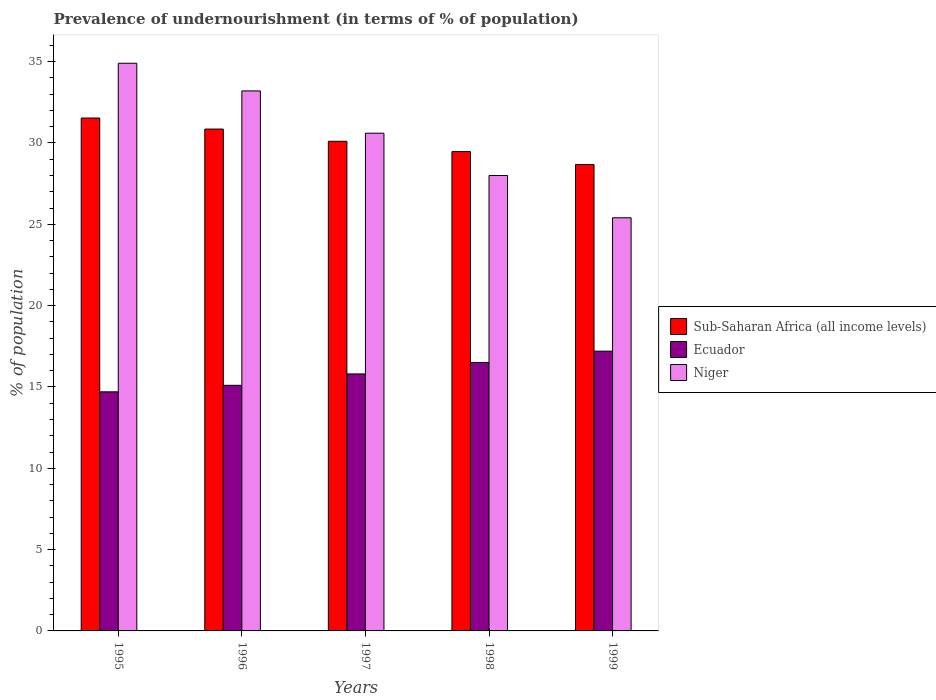How many groups of bars are there?
Make the answer very short. 5. How many bars are there on the 4th tick from the left?
Your answer should be compact. 3. How many bars are there on the 4th tick from the right?
Ensure brevity in your answer.  3. What is the label of the 4th group of bars from the left?
Your answer should be very brief. 1998. In how many cases, is the number of bars for a given year not equal to the number of legend labels?
Your answer should be very brief. 0. What is the percentage of undernourished population in Sub-Saharan Africa (all income levels) in 1996?
Your answer should be very brief. 30.85. Across all years, what is the maximum percentage of undernourished population in Niger?
Make the answer very short. 34.9. Across all years, what is the minimum percentage of undernourished population in Ecuador?
Provide a short and direct response. 14.7. What is the total percentage of undernourished population in Sub-Saharan Africa (all income levels) in the graph?
Give a very brief answer. 150.63. What is the difference between the percentage of undernourished population in Sub-Saharan Africa (all income levels) in 1996 and the percentage of undernourished population in Ecuador in 1995?
Keep it short and to the point. 16.15. What is the average percentage of undernourished population in Niger per year?
Offer a terse response. 30.42. In the year 1996, what is the difference between the percentage of undernourished population in Sub-Saharan Africa (all income levels) and percentage of undernourished population in Niger?
Ensure brevity in your answer.  -2.35. What is the ratio of the percentage of undernourished population in Niger in 1995 to that in 1998?
Provide a succinct answer. 1.25. Is the percentage of undernourished population in Sub-Saharan Africa (all income levels) in 1995 less than that in 1998?
Provide a succinct answer. No. Is the difference between the percentage of undernourished population in Sub-Saharan Africa (all income levels) in 1995 and 1998 greater than the difference between the percentage of undernourished population in Niger in 1995 and 1998?
Your answer should be very brief. No. What is the difference between the highest and the second highest percentage of undernourished population in Niger?
Ensure brevity in your answer.  1.7. Is the sum of the percentage of undernourished population in Ecuador in 1995 and 1997 greater than the maximum percentage of undernourished population in Sub-Saharan Africa (all income levels) across all years?
Give a very brief answer. No. What does the 1st bar from the left in 1997 represents?
Make the answer very short. Sub-Saharan Africa (all income levels). What does the 3rd bar from the right in 1998 represents?
Keep it short and to the point. Sub-Saharan Africa (all income levels). Is it the case that in every year, the sum of the percentage of undernourished population in Ecuador and percentage of undernourished population in Sub-Saharan Africa (all income levels) is greater than the percentage of undernourished population in Niger?
Provide a succinct answer. Yes. How many bars are there?
Offer a very short reply. 15. Are all the bars in the graph horizontal?
Make the answer very short. No. What is the difference between two consecutive major ticks on the Y-axis?
Keep it short and to the point. 5. Does the graph contain any zero values?
Your answer should be compact. No. Where does the legend appear in the graph?
Ensure brevity in your answer.  Center right. What is the title of the graph?
Give a very brief answer. Prevalence of undernourishment (in terms of % of population). What is the label or title of the X-axis?
Your response must be concise. Years. What is the label or title of the Y-axis?
Make the answer very short. % of population. What is the % of population in Sub-Saharan Africa (all income levels) in 1995?
Make the answer very short. 31.53. What is the % of population in Niger in 1995?
Offer a terse response. 34.9. What is the % of population in Sub-Saharan Africa (all income levels) in 1996?
Offer a very short reply. 30.85. What is the % of population in Ecuador in 1996?
Give a very brief answer. 15.1. What is the % of population of Niger in 1996?
Your answer should be compact. 33.2. What is the % of population of Sub-Saharan Africa (all income levels) in 1997?
Your response must be concise. 30.1. What is the % of population in Ecuador in 1997?
Your answer should be compact. 15.8. What is the % of population in Niger in 1997?
Offer a very short reply. 30.6. What is the % of population in Sub-Saharan Africa (all income levels) in 1998?
Offer a terse response. 29.47. What is the % of population in Ecuador in 1998?
Offer a very short reply. 16.5. What is the % of population in Niger in 1998?
Your answer should be compact. 28. What is the % of population of Sub-Saharan Africa (all income levels) in 1999?
Provide a short and direct response. 28.67. What is the % of population of Ecuador in 1999?
Provide a succinct answer. 17.2. What is the % of population in Niger in 1999?
Provide a short and direct response. 25.4. Across all years, what is the maximum % of population in Sub-Saharan Africa (all income levels)?
Offer a very short reply. 31.53. Across all years, what is the maximum % of population of Ecuador?
Ensure brevity in your answer.  17.2. Across all years, what is the maximum % of population in Niger?
Your answer should be very brief. 34.9. Across all years, what is the minimum % of population of Sub-Saharan Africa (all income levels)?
Your answer should be very brief. 28.67. Across all years, what is the minimum % of population of Ecuador?
Your answer should be compact. 14.7. Across all years, what is the minimum % of population of Niger?
Ensure brevity in your answer.  25.4. What is the total % of population of Sub-Saharan Africa (all income levels) in the graph?
Your answer should be very brief. 150.63. What is the total % of population in Ecuador in the graph?
Make the answer very short. 79.3. What is the total % of population of Niger in the graph?
Give a very brief answer. 152.1. What is the difference between the % of population of Sub-Saharan Africa (all income levels) in 1995 and that in 1996?
Offer a very short reply. 0.68. What is the difference between the % of population of Sub-Saharan Africa (all income levels) in 1995 and that in 1997?
Give a very brief answer. 1.43. What is the difference between the % of population in Ecuador in 1995 and that in 1997?
Offer a terse response. -1.1. What is the difference between the % of population in Niger in 1995 and that in 1997?
Provide a succinct answer. 4.3. What is the difference between the % of population of Sub-Saharan Africa (all income levels) in 1995 and that in 1998?
Your answer should be very brief. 2.06. What is the difference between the % of population of Sub-Saharan Africa (all income levels) in 1995 and that in 1999?
Your answer should be very brief. 2.86. What is the difference between the % of population in Niger in 1995 and that in 1999?
Your answer should be very brief. 9.5. What is the difference between the % of population of Sub-Saharan Africa (all income levels) in 1996 and that in 1997?
Your answer should be compact. 0.75. What is the difference between the % of population of Ecuador in 1996 and that in 1997?
Offer a very short reply. -0.7. What is the difference between the % of population in Niger in 1996 and that in 1997?
Your response must be concise. 2.6. What is the difference between the % of population of Sub-Saharan Africa (all income levels) in 1996 and that in 1998?
Your response must be concise. 1.38. What is the difference between the % of population of Ecuador in 1996 and that in 1998?
Ensure brevity in your answer.  -1.4. What is the difference between the % of population in Niger in 1996 and that in 1998?
Offer a terse response. 5.2. What is the difference between the % of population of Sub-Saharan Africa (all income levels) in 1996 and that in 1999?
Offer a terse response. 2.18. What is the difference between the % of population of Ecuador in 1996 and that in 1999?
Your response must be concise. -2.1. What is the difference between the % of population of Sub-Saharan Africa (all income levels) in 1997 and that in 1998?
Your answer should be compact. 0.63. What is the difference between the % of population of Sub-Saharan Africa (all income levels) in 1997 and that in 1999?
Make the answer very short. 1.43. What is the difference between the % of population in Sub-Saharan Africa (all income levels) in 1998 and that in 1999?
Your response must be concise. 0.8. What is the difference between the % of population of Ecuador in 1998 and that in 1999?
Offer a very short reply. -0.7. What is the difference between the % of population in Sub-Saharan Africa (all income levels) in 1995 and the % of population in Ecuador in 1996?
Offer a terse response. 16.43. What is the difference between the % of population in Sub-Saharan Africa (all income levels) in 1995 and the % of population in Niger in 1996?
Offer a very short reply. -1.67. What is the difference between the % of population of Ecuador in 1995 and the % of population of Niger in 1996?
Ensure brevity in your answer.  -18.5. What is the difference between the % of population in Sub-Saharan Africa (all income levels) in 1995 and the % of population in Ecuador in 1997?
Keep it short and to the point. 15.73. What is the difference between the % of population in Sub-Saharan Africa (all income levels) in 1995 and the % of population in Niger in 1997?
Ensure brevity in your answer.  0.93. What is the difference between the % of population of Ecuador in 1995 and the % of population of Niger in 1997?
Your response must be concise. -15.9. What is the difference between the % of population of Sub-Saharan Africa (all income levels) in 1995 and the % of population of Ecuador in 1998?
Give a very brief answer. 15.03. What is the difference between the % of population of Sub-Saharan Africa (all income levels) in 1995 and the % of population of Niger in 1998?
Your answer should be very brief. 3.53. What is the difference between the % of population in Ecuador in 1995 and the % of population in Niger in 1998?
Your answer should be very brief. -13.3. What is the difference between the % of population of Sub-Saharan Africa (all income levels) in 1995 and the % of population of Ecuador in 1999?
Give a very brief answer. 14.33. What is the difference between the % of population of Sub-Saharan Africa (all income levels) in 1995 and the % of population of Niger in 1999?
Ensure brevity in your answer.  6.13. What is the difference between the % of population in Ecuador in 1995 and the % of population in Niger in 1999?
Make the answer very short. -10.7. What is the difference between the % of population of Sub-Saharan Africa (all income levels) in 1996 and the % of population of Ecuador in 1997?
Ensure brevity in your answer.  15.05. What is the difference between the % of population of Sub-Saharan Africa (all income levels) in 1996 and the % of population of Niger in 1997?
Provide a succinct answer. 0.25. What is the difference between the % of population of Ecuador in 1996 and the % of population of Niger in 1997?
Make the answer very short. -15.5. What is the difference between the % of population of Sub-Saharan Africa (all income levels) in 1996 and the % of population of Ecuador in 1998?
Your response must be concise. 14.35. What is the difference between the % of population of Sub-Saharan Africa (all income levels) in 1996 and the % of population of Niger in 1998?
Give a very brief answer. 2.85. What is the difference between the % of population of Ecuador in 1996 and the % of population of Niger in 1998?
Make the answer very short. -12.9. What is the difference between the % of population of Sub-Saharan Africa (all income levels) in 1996 and the % of population of Ecuador in 1999?
Your response must be concise. 13.65. What is the difference between the % of population in Sub-Saharan Africa (all income levels) in 1996 and the % of population in Niger in 1999?
Your answer should be compact. 5.45. What is the difference between the % of population in Sub-Saharan Africa (all income levels) in 1997 and the % of population in Ecuador in 1998?
Your answer should be compact. 13.6. What is the difference between the % of population of Sub-Saharan Africa (all income levels) in 1997 and the % of population of Niger in 1998?
Make the answer very short. 2.1. What is the difference between the % of population of Ecuador in 1997 and the % of population of Niger in 1998?
Give a very brief answer. -12.2. What is the difference between the % of population in Sub-Saharan Africa (all income levels) in 1997 and the % of population in Ecuador in 1999?
Give a very brief answer. 12.9. What is the difference between the % of population in Sub-Saharan Africa (all income levels) in 1997 and the % of population in Niger in 1999?
Your answer should be very brief. 4.7. What is the difference between the % of population in Sub-Saharan Africa (all income levels) in 1998 and the % of population in Ecuador in 1999?
Give a very brief answer. 12.27. What is the difference between the % of population of Sub-Saharan Africa (all income levels) in 1998 and the % of population of Niger in 1999?
Offer a very short reply. 4.07. What is the average % of population in Sub-Saharan Africa (all income levels) per year?
Offer a very short reply. 30.13. What is the average % of population in Ecuador per year?
Make the answer very short. 15.86. What is the average % of population of Niger per year?
Keep it short and to the point. 30.42. In the year 1995, what is the difference between the % of population of Sub-Saharan Africa (all income levels) and % of population of Ecuador?
Provide a succinct answer. 16.83. In the year 1995, what is the difference between the % of population in Sub-Saharan Africa (all income levels) and % of population in Niger?
Give a very brief answer. -3.37. In the year 1995, what is the difference between the % of population in Ecuador and % of population in Niger?
Offer a very short reply. -20.2. In the year 1996, what is the difference between the % of population of Sub-Saharan Africa (all income levels) and % of population of Ecuador?
Your answer should be very brief. 15.75. In the year 1996, what is the difference between the % of population of Sub-Saharan Africa (all income levels) and % of population of Niger?
Keep it short and to the point. -2.35. In the year 1996, what is the difference between the % of population of Ecuador and % of population of Niger?
Your answer should be compact. -18.1. In the year 1997, what is the difference between the % of population of Sub-Saharan Africa (all income levels) and % of population of Ecuador?
Offer a terse response. 14.3. In the year 1997, what is the difference between the % of population of Sub-Saharan Africa (all income levels) and % of population of Niger?
Make the answer very short. -0.5. In the year 1997, what is the difference between the % of population in Ecuador and % of population in Niger?
Your response must be concise. -14.8. In the year 1998, what is the difference between the % of population in Sub-Saharan Africa (all income levels) and % of population in Ecuador?
Your response must be concise. 12.97. In the year 1998, what is the difference between the % of population in Sub-Saharan Africa (all income levels) and % of population in Niger?
Offer a terse response. 1.47. In the year 1998, what is the difference between the % of population of Ecuador and % of population of Niger?
Offer a very short reply. -11.5. In the year 1999, what is the difference between the % of population of Sub-Saharan Africa (all income levels) and % of population of Ecuador?
Provide a succinct answer. 11.47. In the year 1999, what is the difference between the % of population of Sub-Saharan Africa (all income levels) and % of population of Niger?
Offer a terse response. 3.27. What is the ratio of the % of population in Ecuador in 1995 to that in 1996?
Your answer should be compact. 0.97. What is the ratio of the % of population in Niger in 1995 to that in 1996?
Make the answer very short. 1.05. What is the ratio of the % of population of Sub-Saharan Africa (all income levels) in 1995 to that in 1997?
Offer a very short reply. 1.05. What is the ratio of the % of population in Ecuador in 1995 to that in 1997?
Give a very brief answer. 0.93. What is the ratio of the % of population of Niger in 1995 to that in 1997?
Make the answer very short. 1.14. What is the ratio of the % of population in Sub-Saharan Africa (all income levels) in 1995 to that in 1998?
Provide a short and direct response. 1.07. What is the ratio of the % of population in Ecuador in 1995 to that in 1998?
Your answer should be compact. 0.89. What is the ratio of the % of population of Niger in 1995 to that in 1998?
Offer a terse response. 1.25. What is the ratio of the % of population in Sub-Saharan Africa (all income levels) in 1995 to that in 1999?
Provide a succinct answer. 1.1. What is the ratio of the % of population of Ecuador in 1995 to that in 1999?
Give a very brief answer. 0.85. What is the ratio of the % of population in Niger in 1995 to that in 1999?
Offer a very short reply. 1.37. What is the ratio of the % of population in Ecuador in 1996 to that in 1997?
Provide a succinct answer. 0.96. What is the ratio of the % of population in Niger in 1996 to that in 1997?
Provide a succinct answer. 1.08. What is the ratio of the % of population of Sub-Saharan Africa (all income levels) in 1996 to that in 1998?
Keep it short and to the point. 1.05. What is the ratio of the % of population in Ecuador in 1996 to that in 1998?
Provide a short and direct response. 0.92. What is the ratio of the % of population of Niger in 1996 to that in 1998?
Offer a terse response. 1.19. What is the ratio of the % of population in Sub-Saharan Africa (all income levels) in 1996 to that in 1999?
Your response must be concise. 1.08. What is the ratio of the % of population in Ecuador in 1996 to that in 1999?
Ensure brevity in your answer.  0.88. What is the ratio of the % of population of Niger in 1996 to that in 1999?
Provide a short and direct response. 1.31. What is the ratio of the % of population in Sub-Saharan Africa (all income levels) in 1997 to that in 1998?
Make the answer very short. 1.02. What is the ratio of the % of population in Ecuador in 1997 to that in 1998?
Provide a short and direct response. 0.96. What is the ratio of the % of population in Niger in 1997 to that in 1998?
Make the answer very short. 1.09. What is the ratio of the % of population of Sub-Saharan Africa (all income levels) in 1997 to that in 1999?
Offer a very short reply. 1.05. What is the ratio of the % of population in Ecuador in 1997 to that in 1999?
Your answer should be very brief. 0.92. What is the ratio of the % of population in Niger in 1997 to that in 1999?
Your answer should be compact. 1.2. What is the ratio of the % of population of Sub-Saharan Africa (all income levels) in 1998 to that in 1999?
Keep it short and to the point. 1.03. What is the ratio of the % of population in Ecuador in 1998 to that in 1999?
Provide a short and direct response. 0.96. What is the ratio of the % of population in Niger in 1998 to that in 1999?
Ensure brevity in your answer.  1.1. What is the difference between the highest and the second highest % of population of Sub-Saharan Africa (all income levels)?
Ensure brevity in your answer.  0.68. What is the difference between the highest and the second highest % of population in Niger?
Provide a short and direct response. 1.7. What is the difference between the highest and the lowest % of population of Sub-Saharan Africa (all income levels)?
Give a very brief answer. 2.86. 